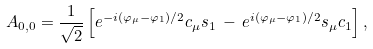Convert formula to latex. <formula><loc_0><loc_0><loc_500><loc_500>A _ { 0 , 0 } = \frac { 1 } { \sqrt { 2 } } \left [ e ^ { - i ( \varphi _ { \mu } - \varphi _ { 1 } ) / 2 } c _ { \mu } s _ { 1 } \, - \, e ^ { i ( \varphi _ { \mu } - \varphi _ { 1 } ) / 2 } s _ { \mu } c _ { 1 } \right ] ,</formula> 